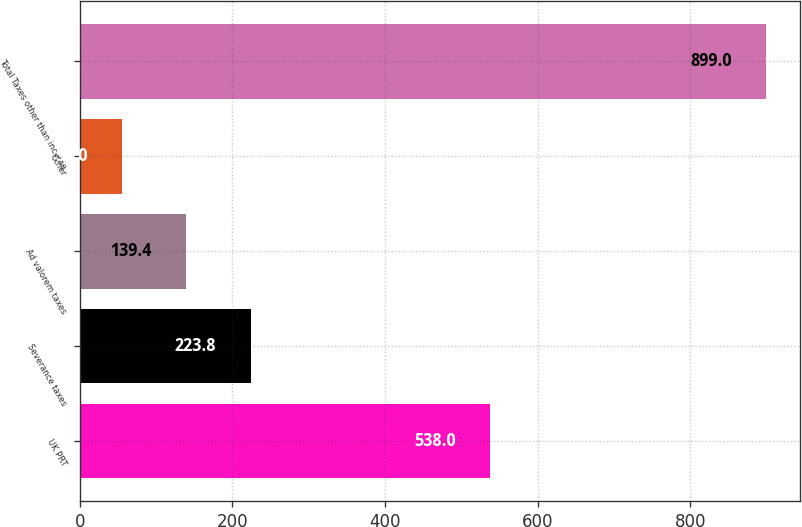Convert chart to OTSL. <chart><loc_0><loc_0><loc_500><loc_500><bar_chart><fcel>UK PRT<fcel>Severance taxes<fcel>Ad valorem taxes<fcel>Other<fcel>Total Taxes other than income<nl><fcel>538<fcel>223.8<fcel>139.4<fcel>55<fcel>899<nl></chart> 